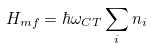<formula> <loc_0><loc_0><loc_500><loc_500>H _ { m f } = \hbar { \omega } _ { C T } \sum _ { i } n _ { i }</formula> 